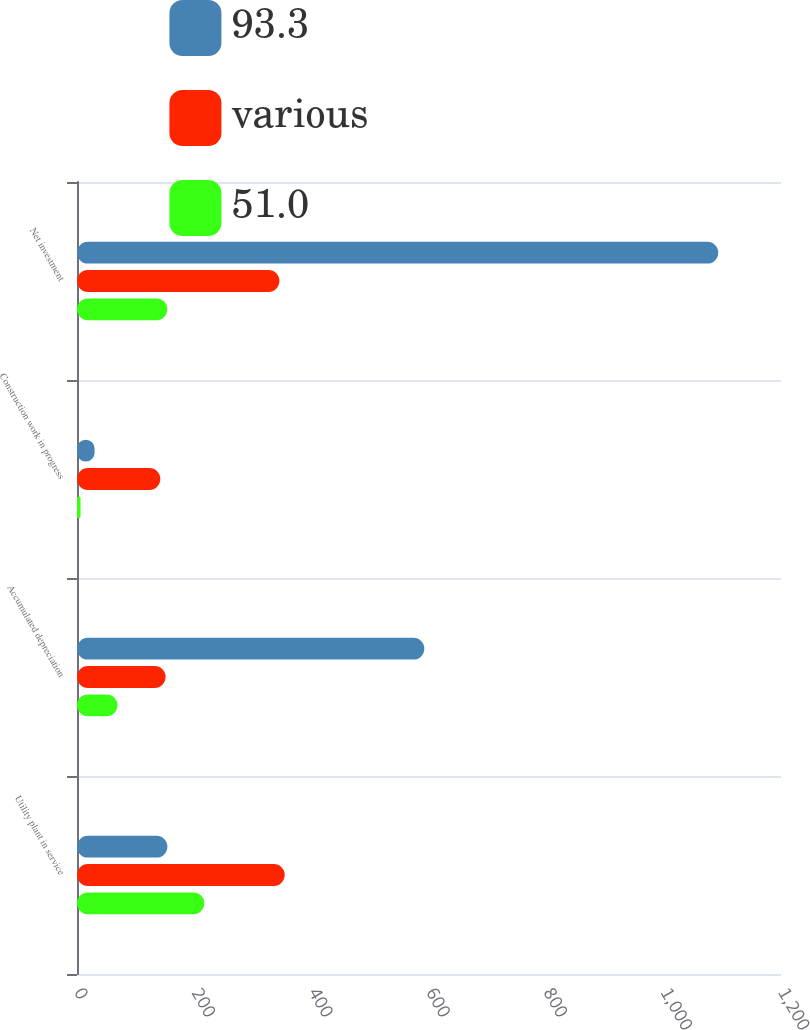<chart> <loc_0><loc_0><loc_500><loc_500><stacked_bar_chart><ecel><fcel>Utility plant in service<fcel>Accumulated depreciation<fcel>Construction work in progress<fcel>Net investment<nl><fcel>93.3<fcel>154<fcel>592<fcel>30<fcel>1093<nl><fcel>various<fcel>354<fcel>151<fcel>142<fcel>345<nl><fcel>51.0<fcel>217<fcel>69<fcel>6<fcel>154<nl></chart> 